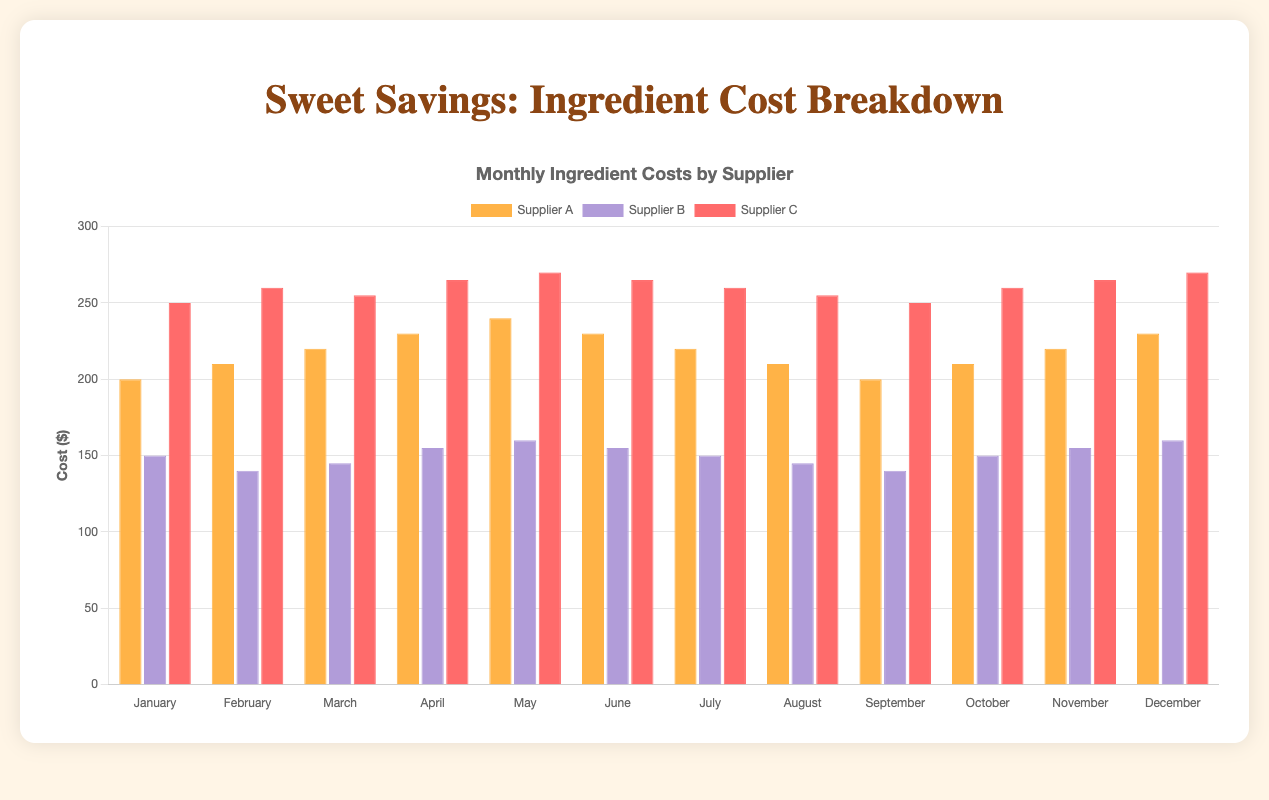Which supplier had the highest flour cost in May? The figure shows costs by supplier and month. For May, check the bar heights for Supplier A, B, and C. The tallest bar is for Supplier A with a value of $240.
Answer: Supplier A Which ingredient had the highest cost in February? Identify the tallest bar for February across all suppliers and ingredients. Butter supplied by Supplier C has the highest cost at $260.
Answer: Butter What's the difference between the sugar costs from Supplier B in January and June? Check the bars for Supplier B in January and June. January's cost is $150, and June's is $155. The difference is $155 - $150 = $5.
Answer: $5 How much is the total cost for flour from Supplier A from January to March combined? Sum the costs for Supplier A's flour from January ($200), February ($210), and March ($220). The total is $200 + $210 + $220 = $630.
Answer: $630 Which month had the lowest cost for butter supplied by Supplier C? Observe the bars for Supplier C's butter across months. January shows the lowest cost at $250.
Answer: January Did the cost of flour from Supplier A increase or decrease from April to May? Compare April ($230) and May ($240) costs for Supplier A's flour. The cost increased from April to May.
Answer: Increased Which supplier had the most consistent flour cost from January to December? Look at the flour bars across months for each supplier. Supplier A's flour cost shows gradual changes without sharp spikes or drops, signifying consistency.
Answer: Supplier A What is the average cost of sugar from Supplier B from March to June? Calculate the average of the sugar costs from March ($145), April ($155), May ($160), and June ($155). The average is ($145 + $155 + $160 + $155) / 4 = $153.75.
Answer: $153.75 In which month did sugar cost more than butter, and which supplier was it? Check the bars for sugar and butter for each month. In May, sugar from Supplier B cost $160, which is less than butter from Supplier C which cost $270.
Answer: None Which supplier had the lowest total cost across all months? Sum the costs for each supplier across all months. Supplier B has the lowest total due to fewer ingredients and consistently lower individual costs.
Answer: Supplier B 